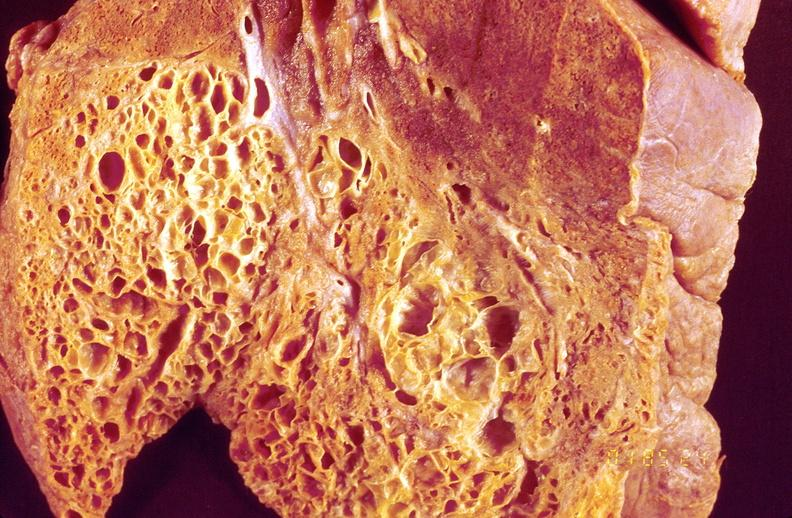s respiratory present?
Answer the question using a single word or phrase. Yes 